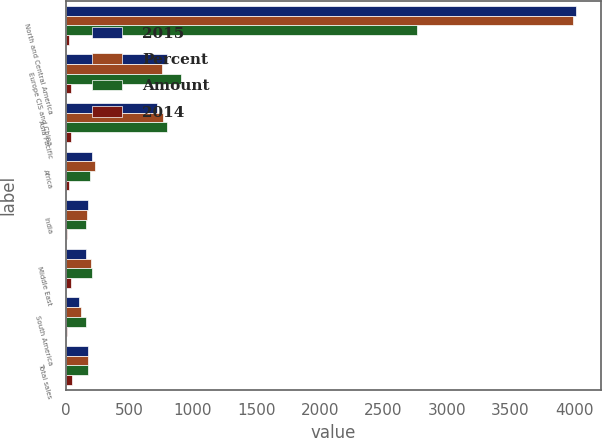Convert chart. <chart><loc_0><loc_0><loc_500><loc_500><stacked_bar_chart><ecel><fcel>North and Central America<fcel>Europe CIS and China<fcel>Asia Pacific<fcel>Africa<fcel>India<fcel>Middle East<fcel>South America<fcel>Total sales<nl><fcel>2015<fcel>4015<fcel>798<fcel>720<fcel>206<fcel>175<fcel>160<fcel>107<fcel>175<nl><fcel>Percent<fcel>3992<fcel>758<fcel>763<fcel>232<fcel>165<fcel>199<fcel>120<fcel>175<nl><fcel>Amount<fcel>2765<fcel>908<fcel>794<fcel>187<fcel>157<fcel>208<fcel>155<fcel>175<nl><fcel>2014<fcel>23<fcel>40<fcel>43<fcel>26<fcel>10<fcel>39<fcel>13<fcel>48<nl></chart> 